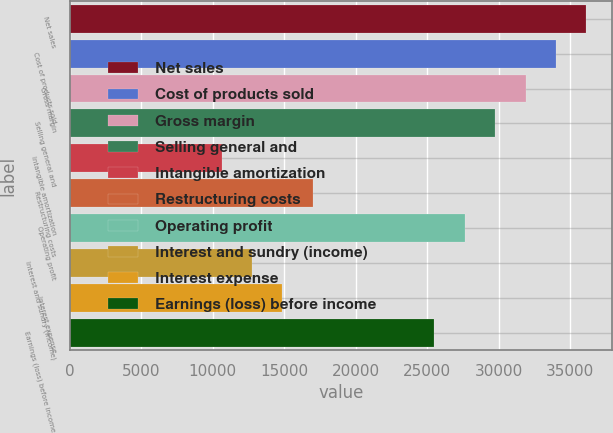Convert chart to OTSL. <chart><loc_0><loc_0><loc_500><loc_500><bar_chart><fcel>Net sales<fcel>Cost of products sold<fcel>Gross margin<fcel>Selling general and<fcel>Intangible amortization<fcel>Restructuring costs<fcel>Operating profit<fcel>Interest and sundry (income)<fcel>Interest expense<fcel>Earnings (loss) before income<nl><fcel>36126.8<fcel>34002<fcel>31877.2<fcel>29752.3<fcel>10628.9<fcel>17003.3<fcel>27627.5<fcel>12753.7<fcel>14878.5<fcel>25502.7<nl></chart> 